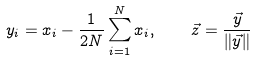Convert formula to latex. <formula><loc_0><loc_0><loc_500><loc_500>y _ { i } = x _ { i } - \frac { 1 } { 2 N } \sum _ { i = 1 } ^ { N } { x _ { i } } , \quad \vec { z } = \frac { \vec { y } } { \| \vec { y } \| }</formula> 